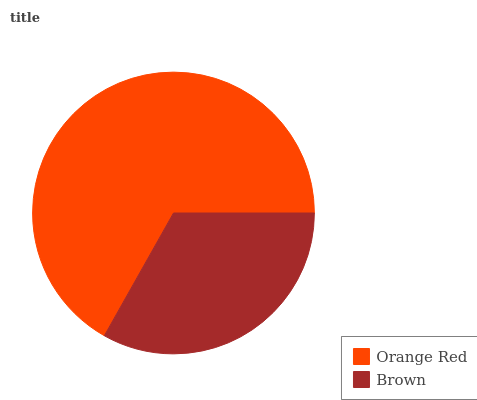Is Brown the minimum?
Answer yes or no. Yes. Is Orange Red the maximum?
Answer yes or no. Yes. Is Brown the maximum?
Answer yes or no. No. Is Orange Red greater than Brown?
Answer yes or no. Yes. Is Brown less than Orange Red?
Answer yes or no. Yes. Is Brown greater than Orange Red?
Answer yes or no. No. Is Orange Red less than Brown?
Answer yes or no. No. Is Orange Red the high median?
Answer yes or no. Yes. Is Brown the low median?
Answer yes or no. Yes. Is Brown the high median?
Answer yes or no. No. Is Orange Red the low median?
Answer yes or no. No. 